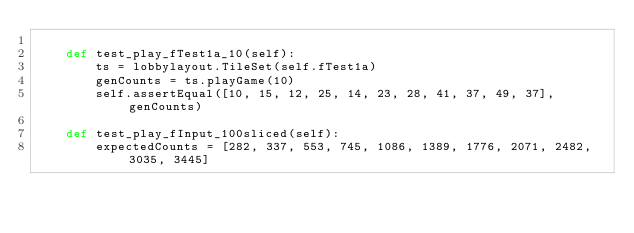Convert code to text. <code><loc_0><loc_0><loc_500><loc_500><_Python_>
    def test_play_fTest1a_10(self):
        ts = lobbylayout.TileSet(self.fTest1a)
        genCounts = ts.playGame(10)
        self.assertEqual([10, 15, 12, 25, 14, 23, 28, 41, 37, 49, 37], genCounts)

    def test_play_fInput_100sliced(self):
        expectedCounts = [282, 337, 553, 745, 1086, 1389, 1776, 2071, 2482, 3035, 3445]</code> 